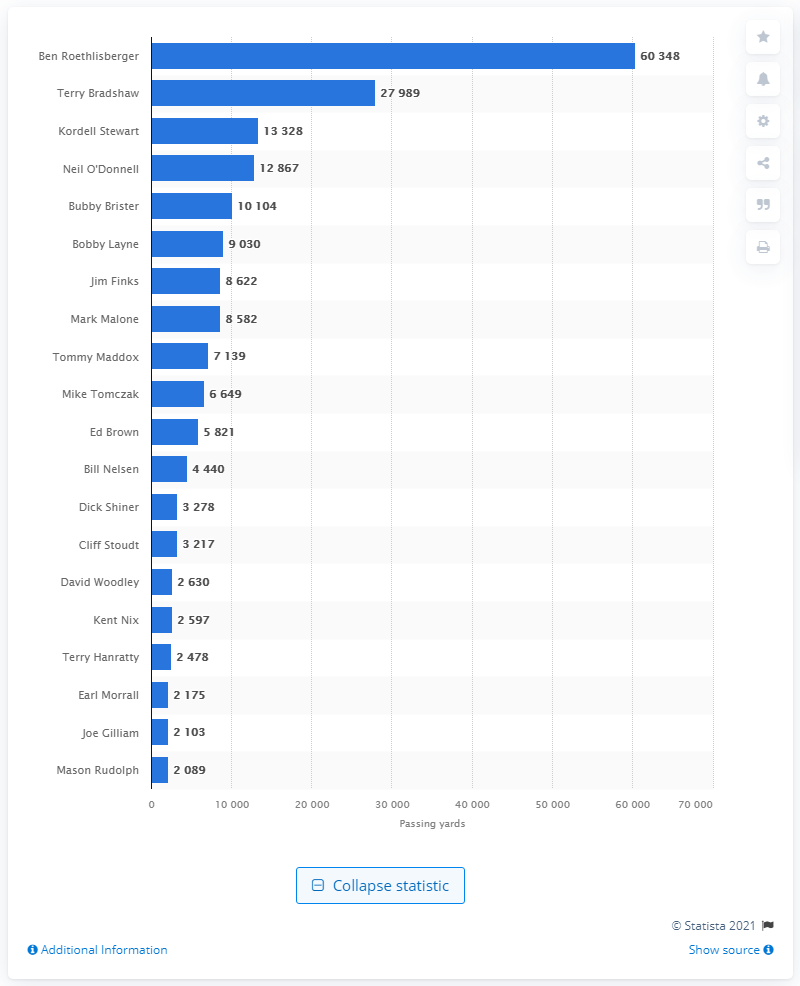Draw attention to some important aspects in this diagram. Ben Roethlisberger is the career passing leader of the Pittsburgh Steelers. 